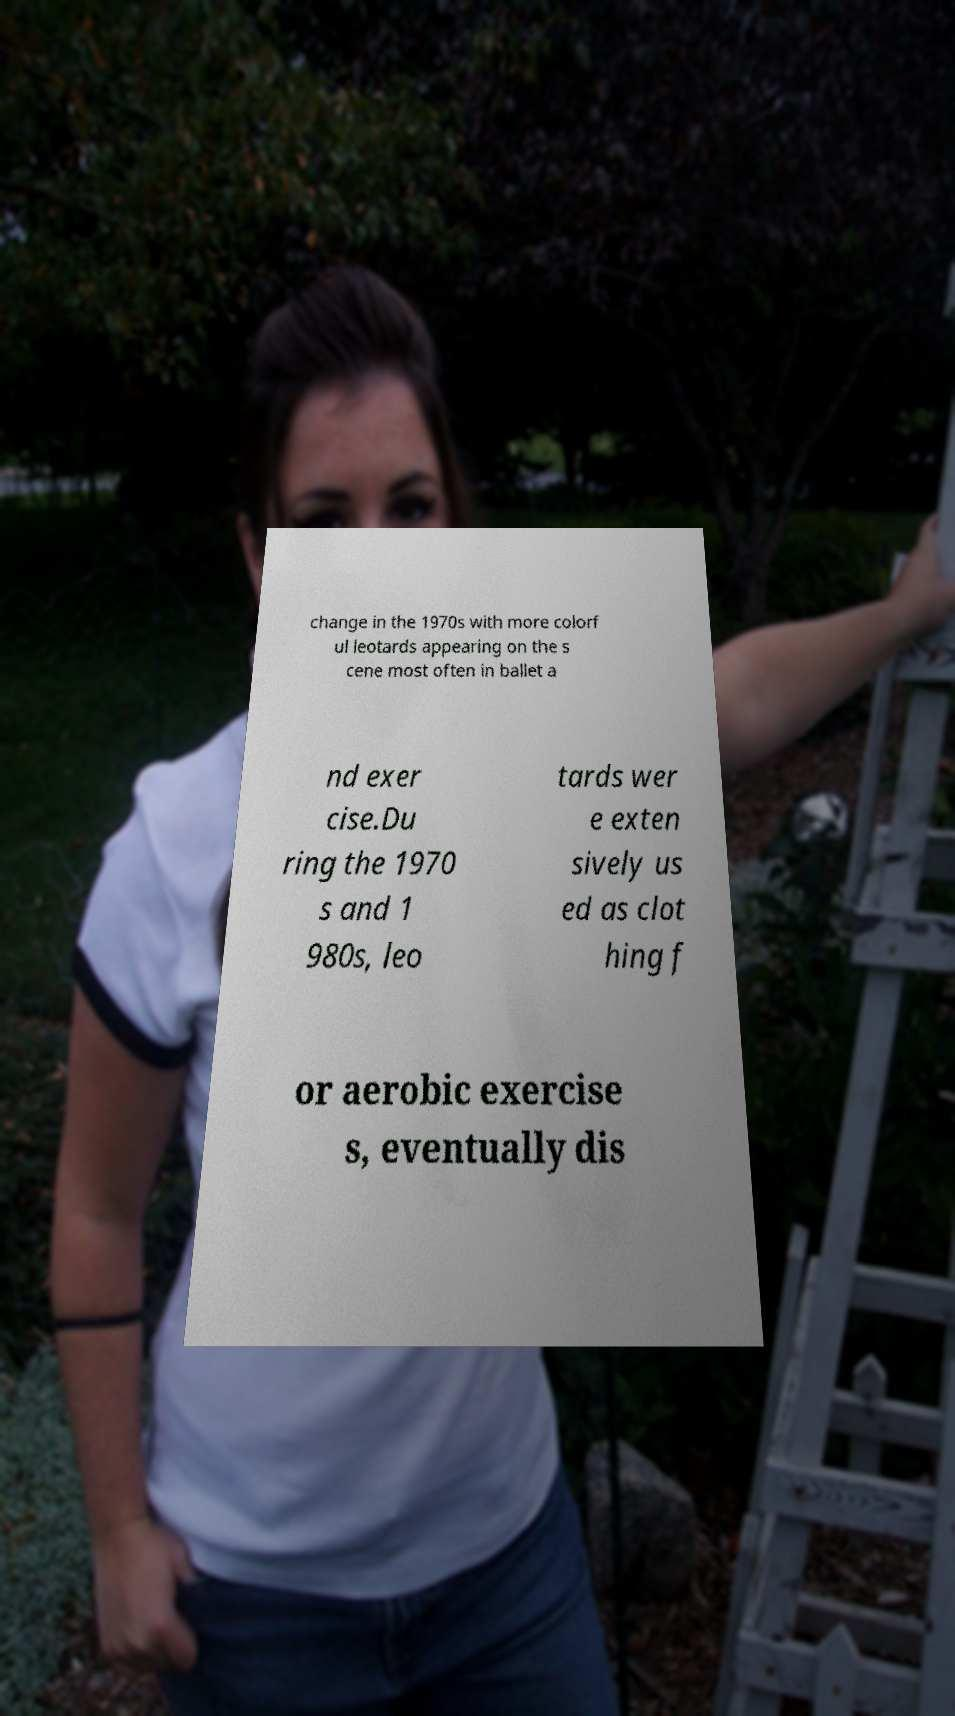What messages or text are displayed in this image? I need them in a readable, typed format. change in the 1970s with more colorf ul leotards appearing on the s cene most often in ballet a nd exer cise.Du ring the 1970 s and 1 980s, leo tards wer e exten sively us ed as clot hing f or aerobic exercise s, eventually dis 